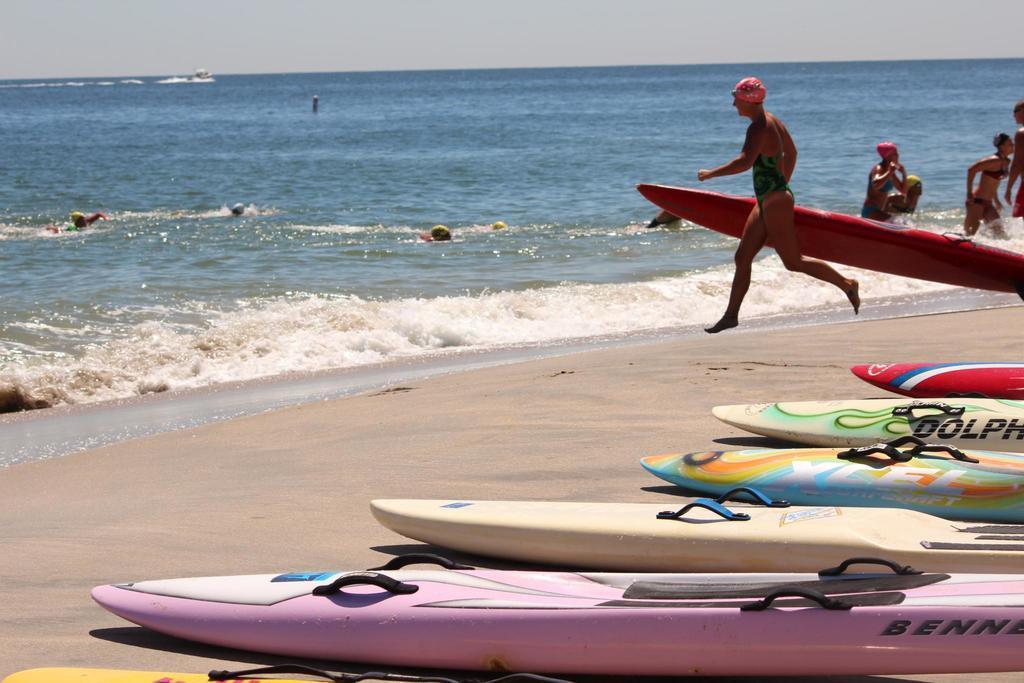<image>
Relay a brief, clear account of the picture shown. A row of stand up paddle boards, one of which says Dolphin on it. 